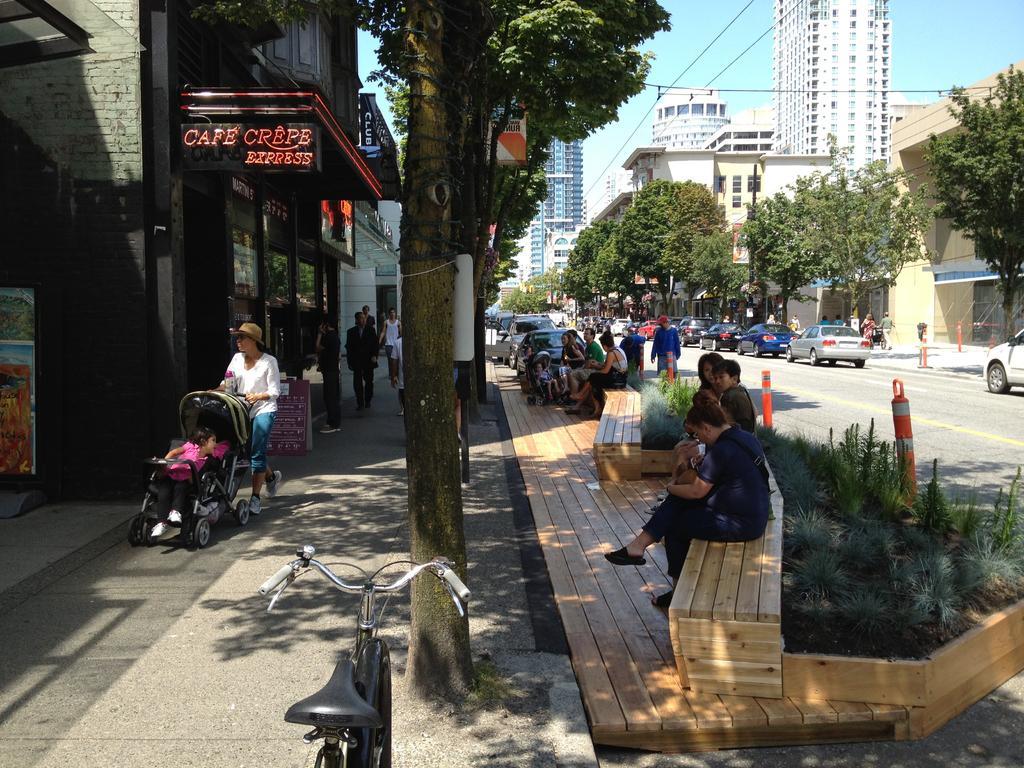Describe this image in one or two sentences. In this image, we can see many people and some are sitting on the benches and we can see vehicles are on the road and there is a bicycle and we can see boards, poles, trees and buildings and some plants. 